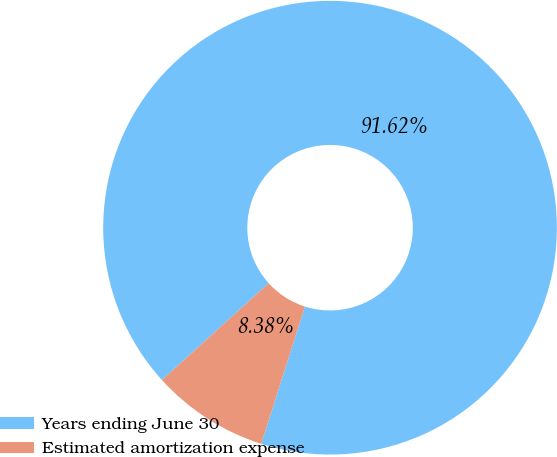Convert chart. <chart><loc_0><loc_0><loc_500><loc_500><pie_chart><fcel>Years ending June 30<fcel>Estimated amortization expense<nl><fcel>91.62%<fcel>8.38%<nl></chart> 